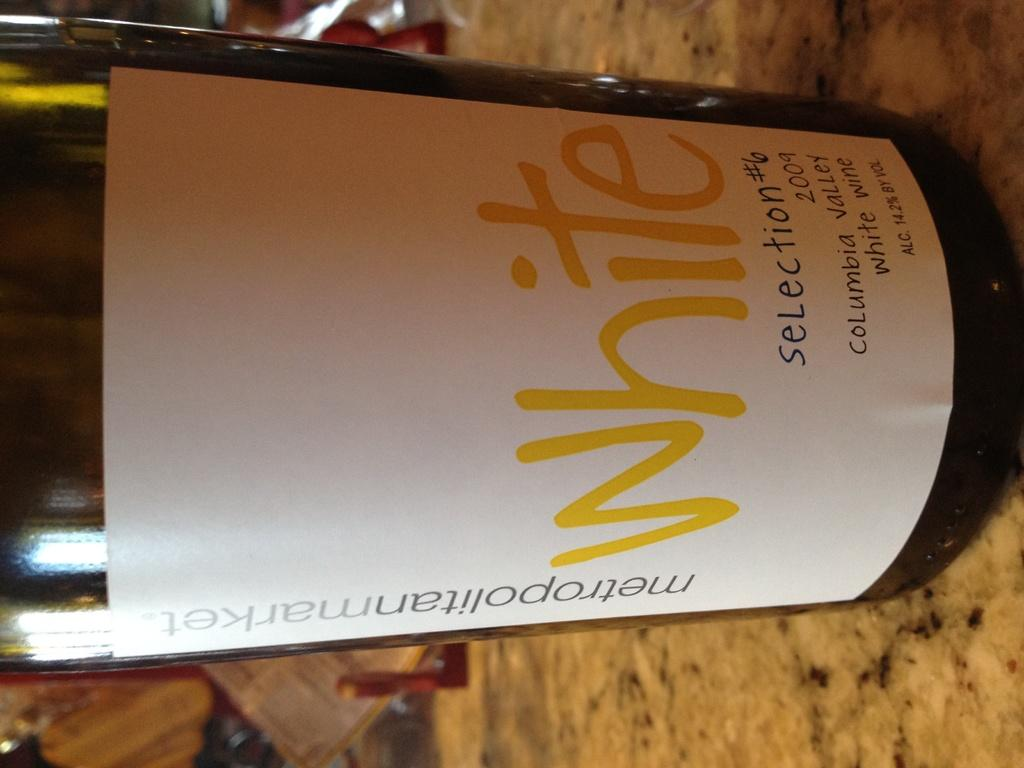<image>
Offer a succinct explanation of the picture presented. A bottle of White Selection #6 sits on a table or bar. 